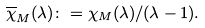Convert formula to latex. <formula><loc_0><loc_0><loc_500><loc_500>\overline { \chi } _ { M } ( \lambda ) \colon = \chi _ { M } ( \lambda ) / ( \lambda - 1 ) .</formula> 